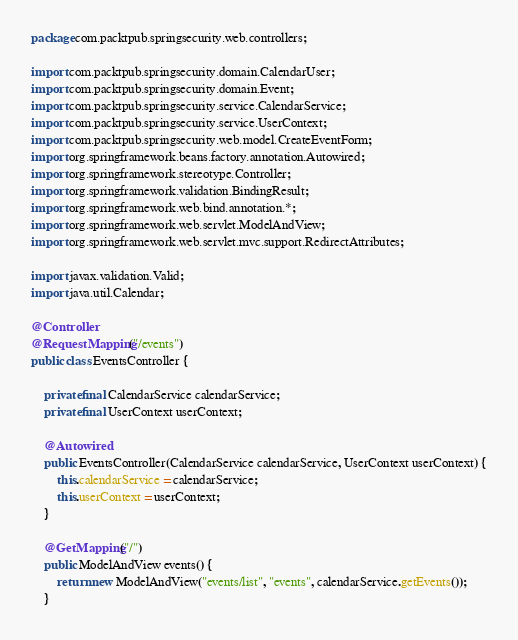<code> <loc_0><loc_0><loc_500><loc_500><_Java_>package com.packtpub.springsecurity.web.controllers;

import com.packtpub.springsecurity.domain.CalendarUser;
import com.packtpub.springsecurity.domain.Event;
import com.packtpub.springsecurity.service.CalendarService;
import com.packtpub.springsecurity.service.UserContext;
import com.packtpub.springsecurity.web.model.CreateEventForm;
import org.springframework.beans.factory.annotation.Autowired;
import org.springframework.stereotype.Controller;
import org.springframework.validation.BindingResult;
import org.springframework.web.bind.annotation.*;
import org.springframework.web.servlet.ModelAndView;
import org.springframework.web.servlet.mvc.support.RedirectAttributes;

import javax.validation.Valid;
import java.util.Calendar;

@Controller
@RequestMapping("/events")
public class EventsController {

    private final CalendarService calendarService;
    private final UserContext userContext;

    @Autowired
    public EventsController(CalendarService calendarService, UserContext userContext) {
        this.calendarService = calendarService;
        this.userContext = userContext;
    }

    @GetMapping("/")
    public ModelAndView events() {
        return new ModelAndView("events/list", "events", calendarService.getEvents());
    }
</code> 